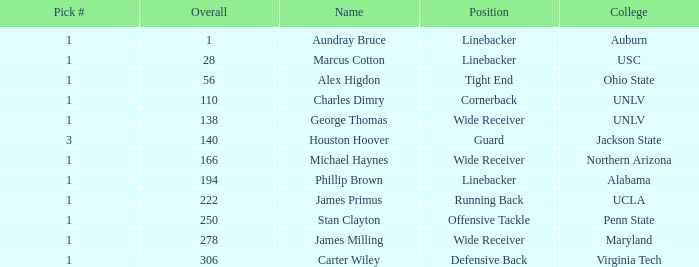In which round did the first pick # exceed 1 and 140 overall? None. 